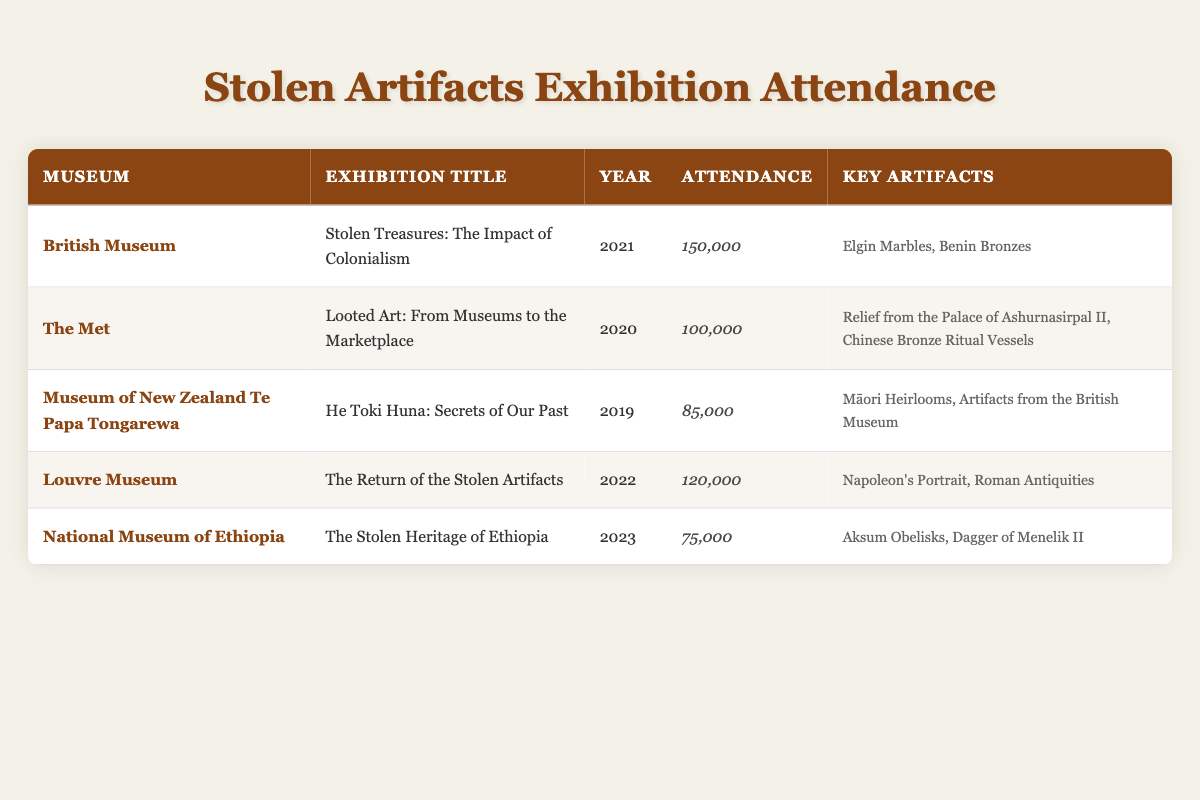What is the title of the exhibition with the highest attendance? The highest attendance is 150,000, which belongs to the exhibition "Stolen Treasures: The Impact of Colonialism" held at the British Museum.
Answer: Stolen Treasures: The Impact of Colonialism How many artifacts are key to the exhibition titled "The Stolen Heritage of Ethiopia"? The exhibition "The Stolen Heritage of Ethiopia" at the National Museum of Ethiopia features 2 key artifacts: Aksum Obelisks and Dagger of Menelik II.
Answer: 2 What is the total attendance of exhibitions held between 2020 and 2022? The total attendance is the sum of the exhibitions held in those years: 100,000 (2020) + 150,000 (2021) + 120,000 (2022) = 370,000.
Answer: 370,000 Did the Museum of New Zealand Te Papa Tongarewa have a higher attendance than the National Museum of Ethiopia in 2023? The Museum of New Zealand Te Papa Tongarewa had an attendance of 85,000 in 2019, while the National Museum of Ethiopia had 75,000 attendance in 2023, so yes, Te Papa had a higher attendance.
Answer: Yes What is the average attendance for exhibitions from 2019 to 2023? The average attendance is calculated by summing the attendances (85,000 + 150,000 + 120,000 + 75,000) and dividing by the number of exhibitions (4): (150,000 + 100,000 + 85,000 + 120,000 + 75,000) = 530,000 / 5 = 106,000.
Answer: 106,000 